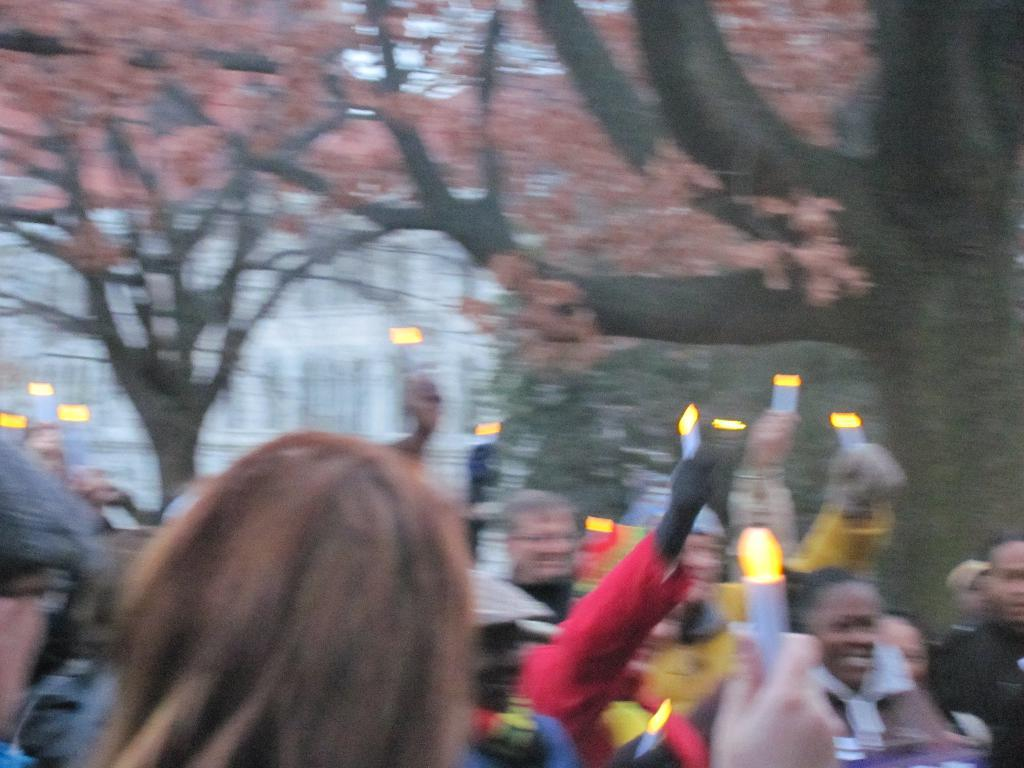What is happening in the image involving a group of people? There is a group of people in the image, and they are standing and holding objects. Can you describe the background of the image? The background of the image includes trees, which are green. What is visible in the sky in the image? The sky is visible in the image, and it is white in color. What type of feather can be seen falling from the sky in the image? There is no feather falling from the sky in the image; the sky is white in color. What is the zinc content of the objects being held by the people in the image? There is no information about the zinc content of the objects being held by the people in the image. 